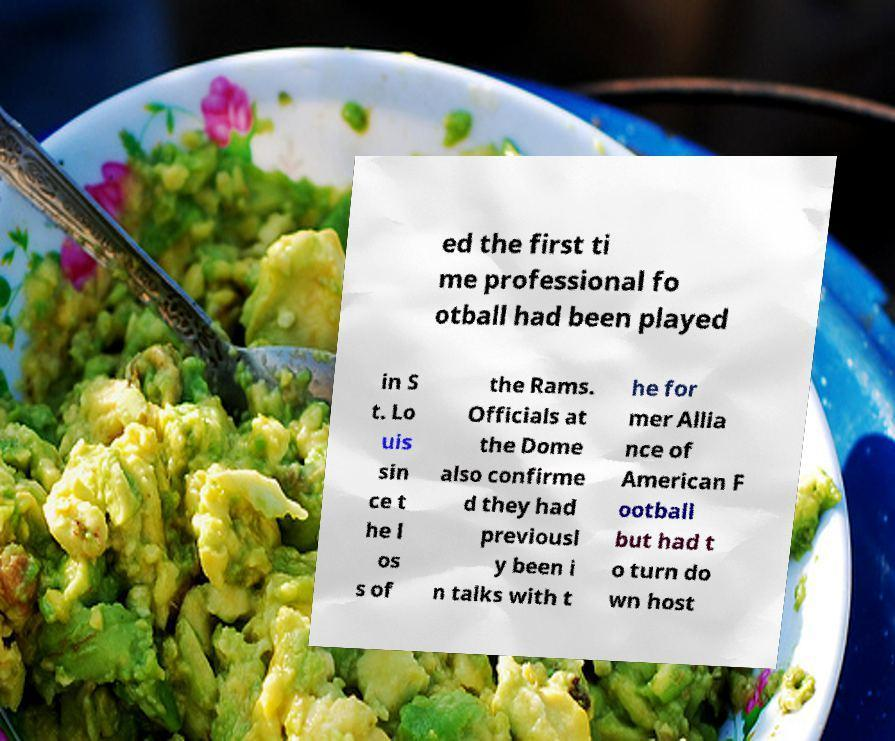Could you extract and type out the text from this image? ed the first ti me professional fo otball had been played in S t. Lo uis sin ce t he l os s of the Rams. Officials at the Dome also confirme d they had previousl y been i n talks with t he for mer Allia nce of American F ootball but had t o turn do wn host 